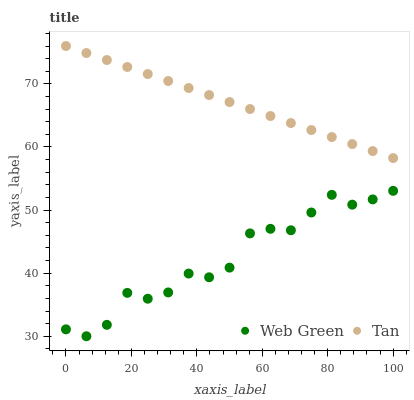Does Web Green have the minimum area under the curve?
Answer yes or no. Yes. Does Tan have the maximum area under the curve?
Answer yes or no. Yes. Does Web Green have the maximum area under the curve?
Answer yes or no. No. Is Tan the smoothest?
Answer yes or no. Yes. Is Web Green the roughest?
Answer yes or no. Yes. Is Web Green the smoothest?
Answer yes or no. No. Does Web Green have the lowest value?
Answer yes or no. Yes. Does Tan have the highest value?
Answer yes or no. Yes. Does Web Green have the highest value?
Answer yes or no. No. Is Web Green less than Tan?
Answer yes or no. Yes. Is Tan greater than Web Green?
Answer yes or no. Yes. Does Web Green intersect Tan?
Answer yes or no. No. 